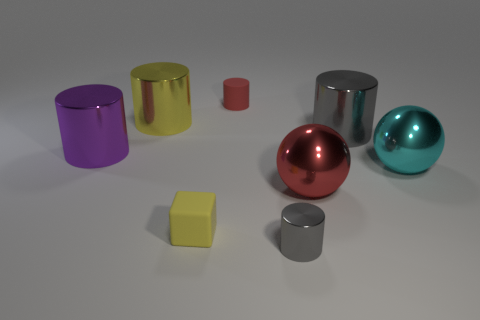Are there fewer big gray rubber cylinders than tiny cubes?
Provide a succinct answer. Yes. How many other tiny rubber cubes have the same color as the small cube?
Provide a succinct answer. 0. There is a big sphere that is to the left of the big gray thing; is it the same color as the tiny matte cylinder?
Provide a short and direct response. Yes. What shape is the red thing that is in front of the purple metallic object?
Provide a succinct answer. Sphere. There is a red thing that is in front of the tiny rubber cylinder; are there any small red matte objects in front of it?
Ensure brevity in your answer.  No. How many large purple cylinders have the same material as the large red thing?
Your answer should be compact. 1. What size is the red thing that is in front of the small cylinder behind the gray cylinder in front of the small cube?
Give a very brief answer. Large. How many red balls are behind the purple cylinder?
Make the answer very short. 0. Is the number of large yellow metal cylinders greater than the number of tiny brown objects?
Your answer should be very brief. Yes. What is the size of the cylinder that is behind the large gray metal cylinder and in front of the red cylinder?
Offer a terse response. Large. 